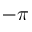<formula> <loc_0><loc_0><loc_500><loc_500>- \pi</formula> 